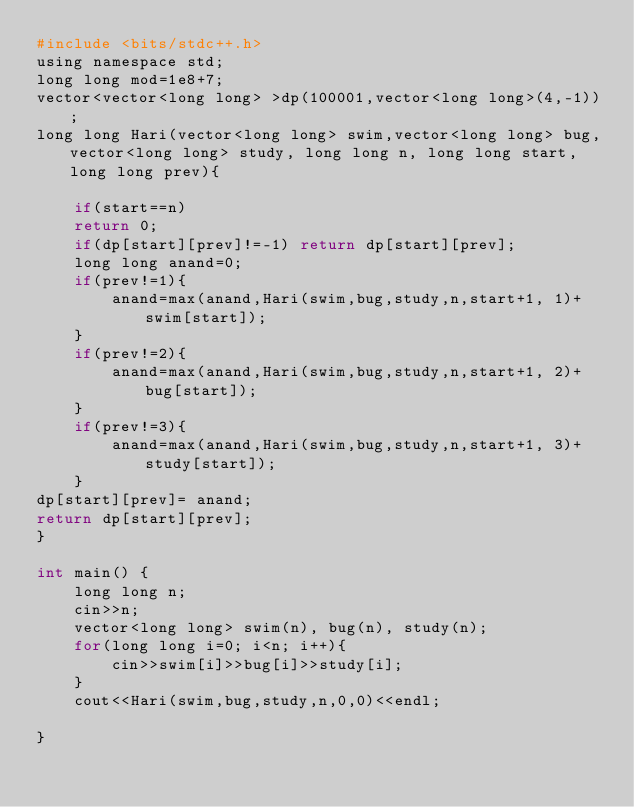<code> <loc_0><loc_0><loc_500><loc_500><_Awk_>#include <bits/stdc++.h> 
using namespace std;
long long mod=1e8+7;
vector<vector<long long> >dp(100001,vector<long long>(4,-1));
long long Hari(vector<long long> swim,vector<long long> bug,vector<long long> study, long long n, long long start, long long prev){
	
	if(start==n)
	return 0;
	if(dp[start][prev]!=-1) return dp[start][prev];
	long long anand=0;
	if(prev!=1){
		anand=max(anand,Hari(swim,bug,study,n,start+1, 1)+swim[start]);
	}
	if(prev!=2){
		anand=max(anand,Hari(swim,bug,study,n,start+1, 2)+bug[start]);
	}
	if(prev!=3){
		anand=max(anand,Hari(swim,bug,study,n,start+1, 3)+study[start]);
	}
dp[start][prev]= anand;
return dp[start][prev];
}
   
int main() {
	long long n;
	cin>>n;
	vector<long long> swim(n), bug(n), study(n);
	for(long long i=0; i<n; i++){
		cin>>swim[i]>>bug[i]>>study[i];
	}
	cout<<Hari(swim,bug,study,n,0,0)<<endl;
	
}</code> 